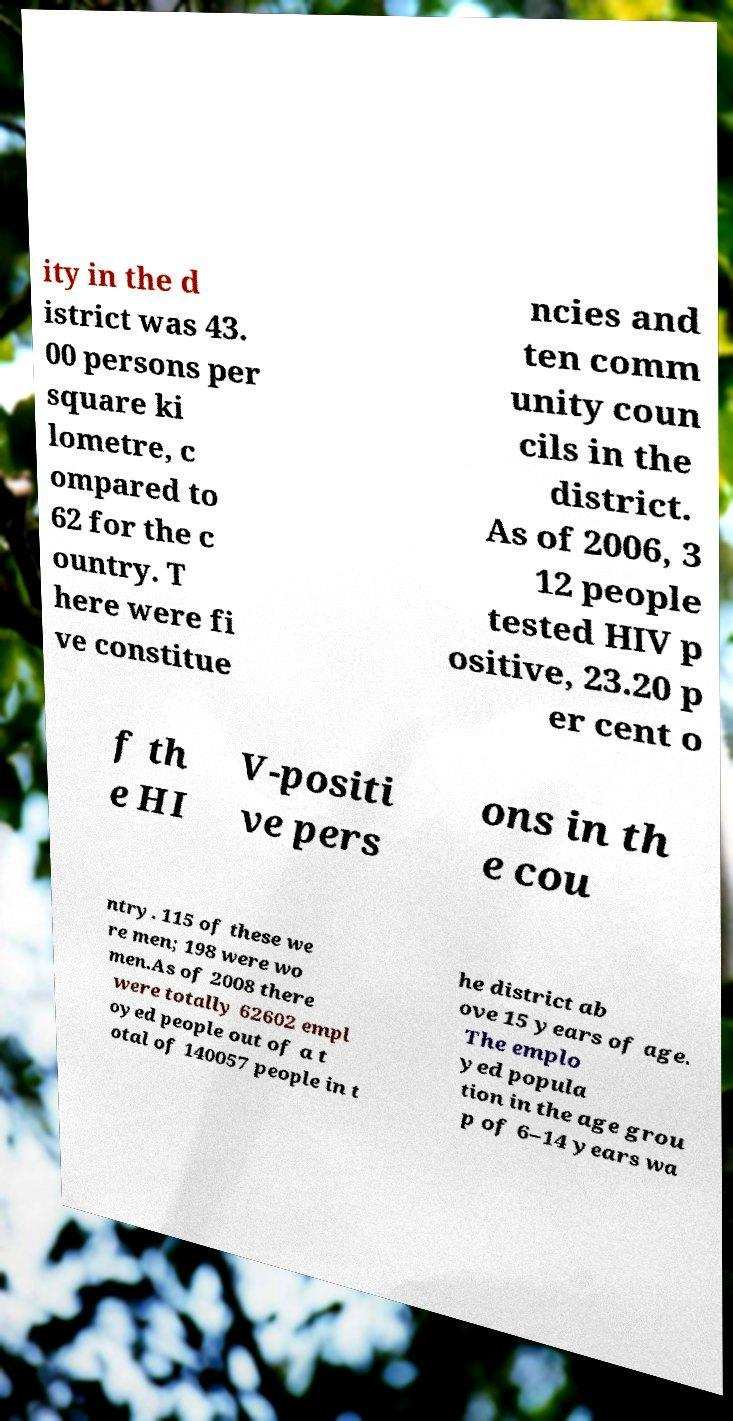Could you assist in decoding the text presented in this image and type it out clearly? ity in the d istrict was 43. 00 persons per square ki lometre, c ompared to 62 for the c ountry. T here were fi ve constitue ncies and ten comm unity coun cils in the district. As of 2006, 3 12 people tested HIV p ositive, 23.20 p er cent o f th e HI V-positi ve pers ons in th e cou ntry. 115 of these we re men; 198 were wo men.As of 2008 there were totally 62602 empl oyed people out of a t otal of 140057 people in t he district ab ove 15 years of age. The emplo yed popula tion in the age grou p of 6–14 years wa 